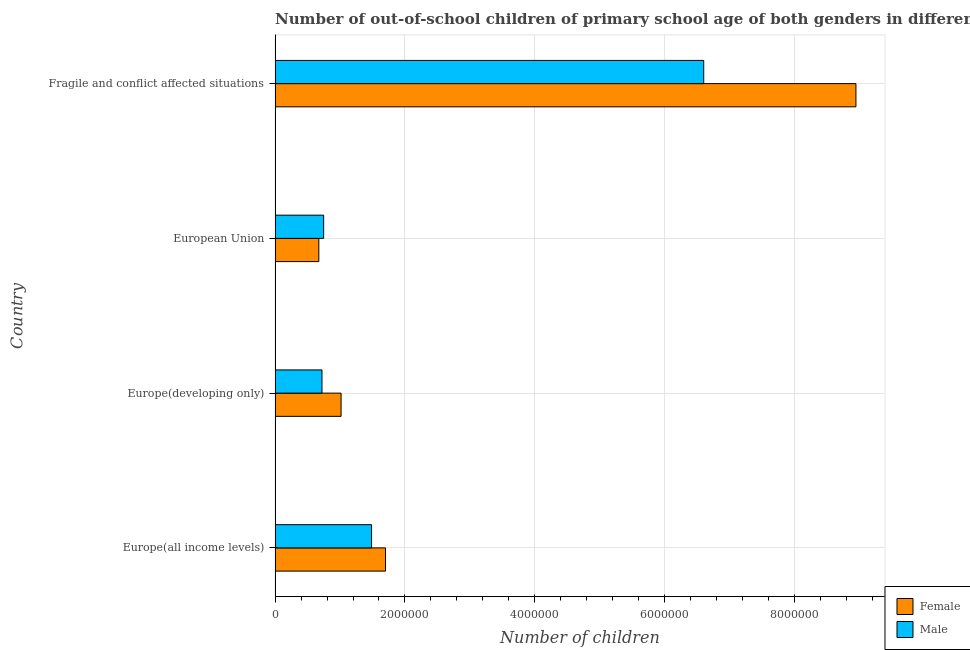What is the label of the 4th group of bars from the top?
Make the answer very short. Europe(all income levels). What is the number of male out-of-school students in Europe(all income levels)?
Your response must be concise. 1.49e+06. Across all countries, what is the maximum number of male out-of-school students?
Provide a short and direct response. 6.60e+06. Across all countries, what is the minimum number of male out-of-school students?
Offer a terse response. 7.22e+05. In which country was the number of male out-of-school students maximum?
Give a very brief answer. Fragile and conflict affected situations. In which country was the number of male out-of-school students minimum?
Give a very brief answer. Europe(developing only). What is the total number of female out-of-school students in the graph?
Your answer should be very brief. 1.23e+07. What is the difference between the number of male out-of-school students in Europe(all income levels) and that in Fragile and conflict affected situations?
Give a very brief answer. -5.11e+06. What is the difference between the number of male out-of-school students in Europe(developing only) and the number of female out-of-school students in European Union?
Keep it short and to the point. 4.87e+04. What is the average number of female out-of-school students per country?
Keep it short and to the point. 3.08e+06. What is the difference between the number of female out-of-school students and number of male out-of-school students in Fragile and conflict affected situations?
Give a very brief answer. 2.34e+06. What is the ratio of the number of male out-of-school students in Europe(all income levels) to that in Fragile and conflict affected situations?
Give a very brief answer. 0.23. Is the number of male out-of-school students in Europe(developing only) less than that in Fragile and conflict affected situations?
Your answer should be compact. Yes. Is the difference between the number of male out-of-school students in Europe(all income levels) and Europe(developing only) greater than the difference between the number of female out-of-school students in Europe(all income levels) and Europe(developing only)?
Offer a terse response. Yes. What is the difference between the highest and the second highest number of female out-of-school students?
Offer a terse response. 7.24e+06. What is the difference between the highest and the lowest number of female out-of-school students?
Ensure brevity in your answer.  8.27e+06. Is the sum of the number of female out-of-school students in Europe(developing only) and European Union greater than the maximum number of male out-of-school students across all countries?
Provide a short and direct response. No. What does the 1st bar from the top in Europe(developing only) represents?
Offer a very short reply. Male. What does the 1st bar from the bottom in Europe(all income levels) represents?
Offer a very short reply. Female. How many countries are there in the graph?
Your answer should be compact. 4. Does the graph contain any zero values?
Your answer should be very brief. No. How many legend labels are there?
Your response must be concise. 2. How are the legend labels stacked?
Make the answer very short. Vertical. What is the title of the graph?
Make the answer very short. Number of out-of-school children of primary school age of both genders in different countries. What is the label or title of the X-axis?
Keep it short and to the point. Number of children. What is the Number of children of Female in Europe(all income levels)?
Ensure brevity in your answer.  1.70e+06. What is the Number of children of Male in Europe(all income levels)?
Keep it short and to the point. 1.49e+06. What is the Number of children in Female in Europe(developing only)?
Your answer should be compact. 1.02e+06. What is the Number of children in Male in Europe(developing only)?
Offer a very short reply. 7.22e+05. What is the Number of children in Female in European Union?
Your answer should be compact. 6.74e+05. What is the Number of children in Male in European Union?
Make the answer very short. 7.48e+05. What is the Number of children in Female in Fragile and conflict affected situations?
Your answer should be very brief. 8.94e+06. What is the Number of children of Male in Fragile and conflict affected situations?
Provide a succinct answer. 6.60e+06. Across all countries, what is the maximum Number of children in Female?
Make the answer very short. 8.94e+06. Across all countries, what is the maximum Number of children of Male?
Offer a terse response. 6.60e+06. Across all countries, what is the minimum Number of children in Female?
Make the answer very short. 6.74e+05. Across all countries, what is the minimum Number of children of Male?
Ensure brevity in your answer.  7.22e+05. What is the total Number of children of Female in the graph?
Ensure brevity in your answer.  1.23e+07. What is the total Number of children in Male in the graph?
Give a very brief answer. 9.56e+06. What is the difference between the Number of children in Female in Europe(all income levels) and that in Europe(developing only)?
Your answer should be very brief. 6.84e+05. What is the difference between the Number of children of Male in Europe(all income levels) and that in Europe(developing only)?
Your answer should be very brief. 7.64e+05. What is the difference between the Number of children in Female in Europe(all income levels) and that in European Union?
Give a very brief answer. 1.03e+06. What is the difference between the Number of children of Male in Europe(all income levels) and that in European Union?
Offer a very short reply. 7.38e+05. What is the difference between the Number of children in Female in Europe(all income levels) and that in Fragile and conflict affected situations?
Your answer should be compact. -7.24e+06. What is the difference between the Number of children in Male in Europe(all income levels) and that in Fragile and conflict affected situations?
Your answer should be very brief. -5.11e+06. What is the difference between the Number of children of Female in Europe(developing only) and that in European Union?
Ensure brevity in your answer.  3.43e+05. What is the difference between the Number of children in Male in Europe(developing only) and that in European Union?
Your response must be concise. -2.56e+04. What is the difference between the Number of children in Female in Europe(developing only) and that in Fragile and conflict affected situations?
Your answer should be compact. -7.93e+06. What is the difference between the Number of children in Male in Europe(developing only) and that in Fragile and conflict affected situations?
Make the answer very short. -5.88e+06. What is the difference between the Number of children of Female in European Union and that in Fragile and conflict affected situations?
Ensure brevity in your answer.  -8.27e+06. What is the difference between the Number of children of Male in European Union and that in Fragile and conflict affected situations?
Ensure brevity in your answer.  -5.85e+06. What is the difference between the Number of children of Female in Europe(all income levels) and the Number of children of Male in Europe(developing only)?
Give a very brief answer. 9.78e+05. What is the difference between the Number of children of Female in Europe(all income levels) and the Number of children of Male in European Union?
Provide a succinct answer. 9.53e+05. What is the difference between the Number of children of Female in Europe(all income levels) and the Number of children of Male in Fragile and conflict affected situations?
Your answer should be compact. -4.90e+06. What is the difference between the Number of children of Female in Europe(developing only) and the Number of children of Male in European Union?
Your answer should be compact. 2.68e+05. What is the difference between the Number of children in Female in Europe(developing only) and the Number of children in Male in Fragile and conflict affected situations?
Keep it short and to the point. -5.58e+06. What is the difference between the Number of children in Female in European Union and the Number of children in Male in Fragile and conflict affected situations?
Keep it short and to the point. -5.93e+06. What is the average Number of children of Female per country?
Provide a succinct answer. 3.08e+06. What is the average Number of children of Male per country?
Offer a terse response. 2.39e+06. What is the difference between the Number of children of Female and Number of children of Male in Europe(all income levels)?
Provide a short and direct response. 2.15e+05. What is the difference between the Number of children in Female and Number of children in Male in Europe(developing only)?
Your answer should be very brief. 2.94e+05. What is the difference between the Number of children in Female and Number of children in Male in European Union?
Provide a succinct answer. -7.43e+04. What is the difference between the Number of children in Female and Number of children in Male in Fragile and conflict affected situations?
Offer a terse response. 2.34e+06. What is the ratio of the Number of children in Female in Europe(all income levels) to that in Europe(developing only)?
Provide a short and direct response. 1.67. What is the ratio of the Number of children in Male in Europe(all income levels) to that in Europe(developing only)?
Keep it short and to the point. 2.06. What is the ratio of the Number of children of Female in Europe(all income levels) to that in European Union?
Ensure brevity in your answer.  2.52. What is the ratio of the Number of children in Male in Europe(all income levels) to that in European Union?
Offer a terse response. 1.99. What is the ratio of the Number of children of Female in Europe(all income levels) to that in Fragile and conflict affected situations?
Ensure brevity in your answer.  0.19. What is the ratio of the Number of children of Male in Europe(all income levels) to that in Fragile and conflict affected situations?
Give a very brief answer. 0.23. What is the ratio of the Number of children of Female in Europe(developing only) to that in European Union?
Provide a succinct answer. 1.51. What is the ratio of the Number of children of Male in Europe(developing only) to that in European Union?
Your answer should be very brief. 0.97. What is the ratio of the Number of children of Female in Europe(developing only) to that in Fragile and conflict affected situations?
Offer a very short reply. 0.11. What is the ratio of the Number of children of Male in Europe(developing only) to that in Fragile and conflict affected situations?
Offer a terse response. 0.11. What is the ratio of the Number of children in Female in European Union to that in Fragile and conflict affected situations?
Ensure brevity in your answer.  0.08. What is the ratio of the Number of children of Male in European Union to that in Fragile and conflict affected situations?
Provide a succinct answer. 0.11. What is the difference between the highest and the second highest Number of children of Female?
Your answer should be very brief. 7.24e+06. What is the difference between the highest and the second highest Number of children in Male?
Keep it short and to the point. 5.11e+06. What is the difference between the highest and the lowest Number of children in Female?
Provide a succinct answer. 8.27e+06. What is the difference between the highest and the lowest Number of children of Male?
Offer a terse response. 5.88e+06. 